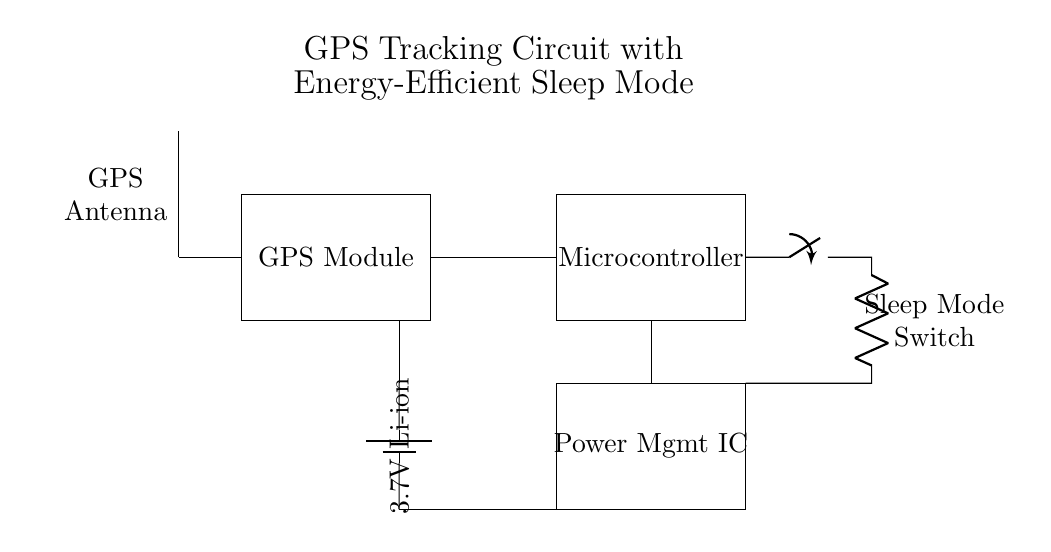What is the main purpose of the GPS module in this circuit? The GPS module's main purpose is to receive signals from satellites to determine the position of the device in order to map isolated communities.
Answer: Mapping What type of battery is used in this circuit? The label indicates a 3.7V Li-ion battery is used, which provides adequate voltage for the components in the circuit.
Answer: Li-ion What component manages the power in the circuit? The Power Management IC is the component responsible for managing the power distribution and efficiency in the circuit.
Answer: Power Management IC How does the sleep mode switch function in this circuit? The sleep mode switch disconnects the microcontroller from power, significantly reducing energy consumption when the device is not in use.
Answer: Disconnect Which component receives signals from the GPS antenna? The GPS module receives signals from the GPS antenna, allowing it to process satellite data for location tracking.
Answer: GPS Module What connection type is used between the GPS module and the microcontroller? A direct electrical connection (represented as a line in the diagram) is used to facilitate data communication between the GPS module and the microcontroller.
Answer: Direct connection What does the switch control related to energy efficiency? The switch controls the activation of the sleep mode, allowing the circuit to enter a low-power state to conserve battery life when not in use.
Answer: Sleep mode 